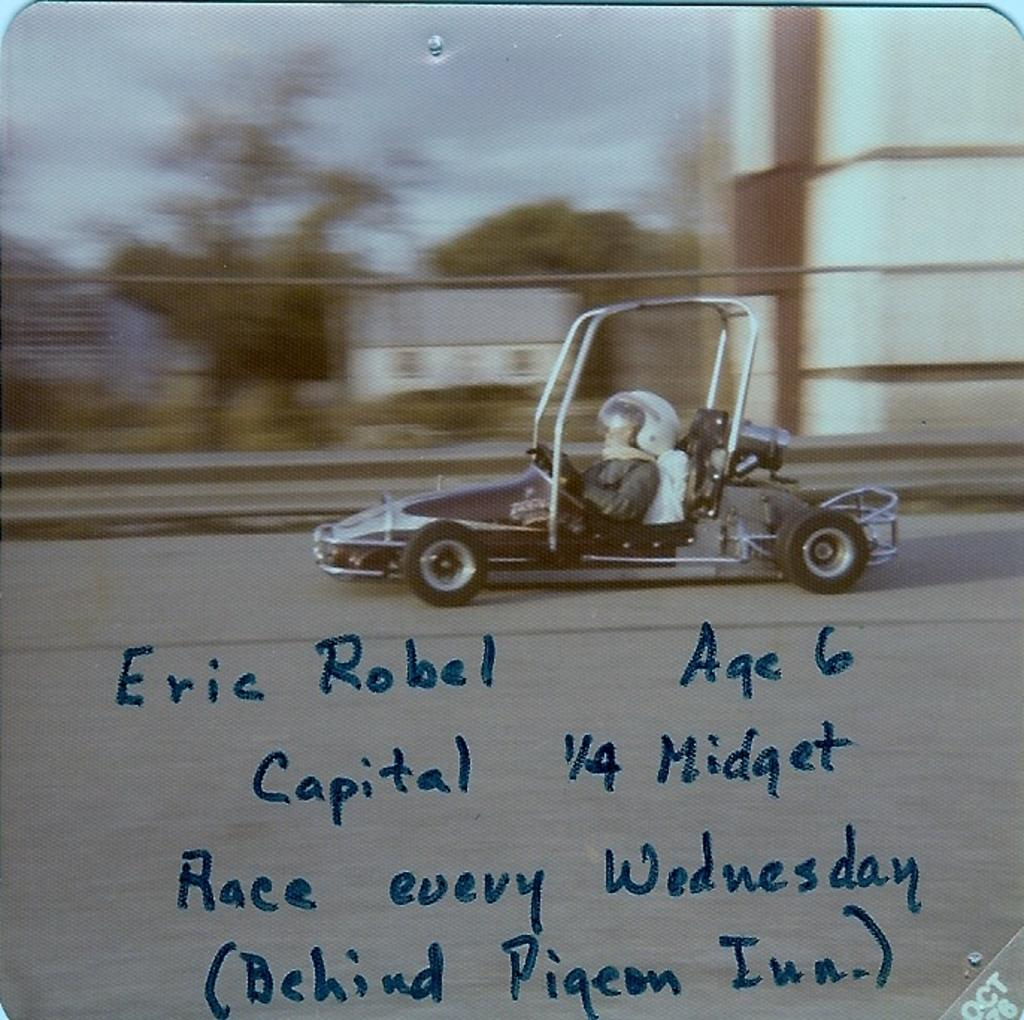Who is present in the image? There is a man in the image. What is the man doing in the image? The man is riding a car. What can be seen in the background of the image? There are trees and buildings in the background of the image. Where is the locket located in the image? There is no locket present in the image. How many beds can be seen in the image? There are no beds present in the image. 